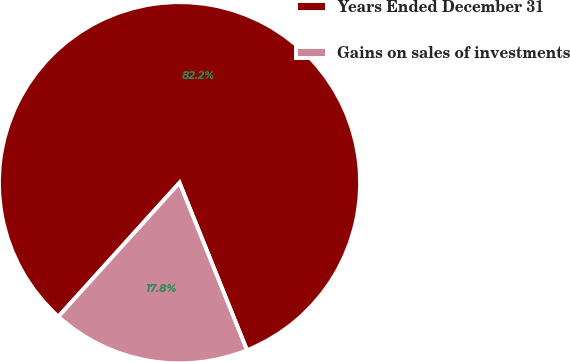<chart> <loc_0><loc_0><loc_500><loc_500><pie_chart><fcel>Years Ended December 31<fcel>Gains on sales of investments<nl><fcel>82.2%<fcel>17.8%<nl></chart> 